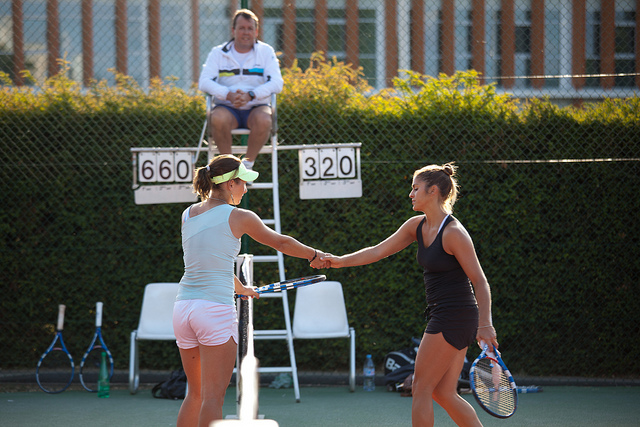Please transcribe the text information in this image. 320 660 